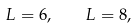Convert formula to latex. <formula><loc_0><loc_0><loc_500><loc_500>L = 6 , \quad L = 8 ,</formula> 